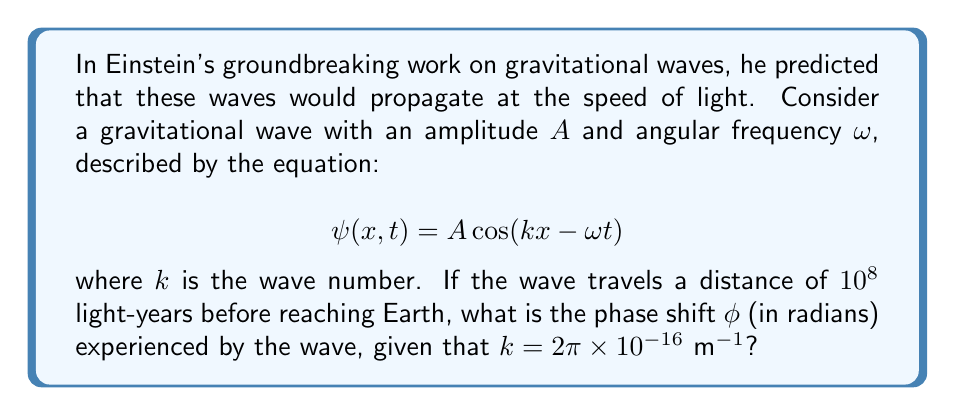Can you solve this math problem? To solve this problem, we'll follow these steps:

1) The phase shift $\phi$ is given by $kx$, where $x$ is the distance traveled.

2) We need to convert the distance from light-years to meters:
   
   1 light-year = $9.461 \times 10^{15}$ m
   
   $10^8$ light-years = $10^8 \times 9.461 \times 10^{15}$ m = $9.461 \times 10^{23}$ m

3) Now we can calculate the phase shift:

   $$\phi = kx = (2\pi \times 10^{-16} \text{ m}^{-1})(9.461 \times 10^{23} \text{ m})$$

4) Simplify:
   
   $$\phi = 2\pi \times 10^{-16} \times 9.461 \times 10^{23} = 2\pi \times 9.461 \times 10^7$$

5) Calculate the final result:
   
   $$\phi \approx 5.94 \times 10^8 \text{ radians}$$

This large phase shift demonstrates the vast distances gravitational waves can travel, as predicted by Einstein, while maintaining their wave-like properties.
Answer: $5.94 \times 10^8$ radians 